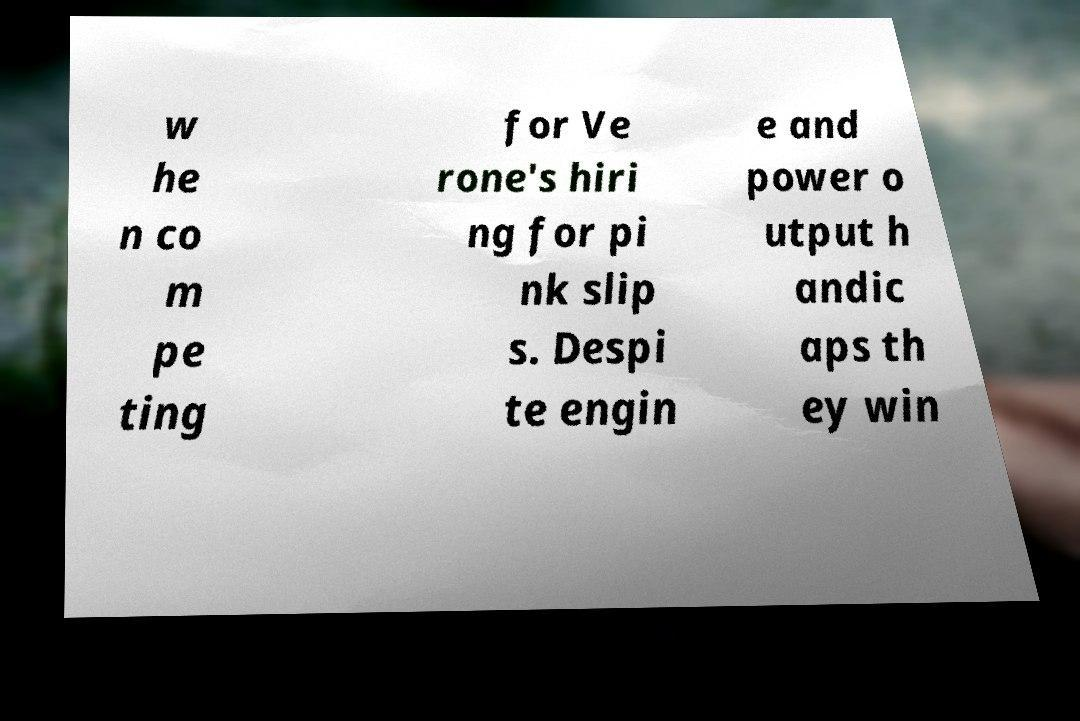There's text embedded in this image that I need extracted. Can you transcribe it verbatim? w he n co m pe ting for Ve rone's hiri ng for pi nk slip s. Despi te engin e and power o utput h andic aps th ey win 